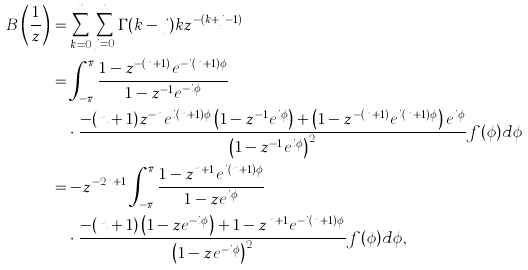Convert formula to latex. <formula><loc_0><loc_0><loc_500><loc_500>B \left ( \frac { 1 } { z } \right ) & = \sum _ { k = 0 } ^ { n } { \sum _ { j = 0 } ^ { n } { \Gamma ( k - j ) k z ^ { - ( k + j - 1 ) } } } \\ & = \int _ { - \pi } ^ { \pi } \frac { 1 - z ^ { - ( n + 1 ) } e ^ { - i ( n + 1 ) \phi } } { 1 - z ^ { - 1 } e ^ { - i \phi } } \\ & \quad \cdot \frac { - ( n + 1 ) z ^ { - n } e ^ { i ( n + 1 ) \phi } \left ( 1 - z ^ { - 1 } e ^ { i \phi } \right ) + \left ( 1 - z ^ { - ( n + 1 ) } e ^ { i ( n + 1 ) \phi } \right ) e ^ { i \phi } } { \left ( 1 - z ^ { - 1 } e ^ { i \phi } \right ) ^ { 2 } } f ( \phi ) d \phi \\ & = - z ^ { - 2 n + 1 } \int _ { - \pi } ^ { \pi } \frac { 1 - z ^ { n + 1 } e ^ { i ( n + 1 ) \phi } } { 1 - z e ^ { i \phi } } \\ & \quad \cdot \frac { - ( n + 1 ) \left ( 1 - z e ^ { - i \phi } \right ) + 1 - z ^ { n + 1 } e ^ { - i ( n + 1 ) \phi } } { \left ( 1 - z e ^ { - i \phi } \right ) ^ { 2 } } f ( \phi ) d \phi , \\</formula> 